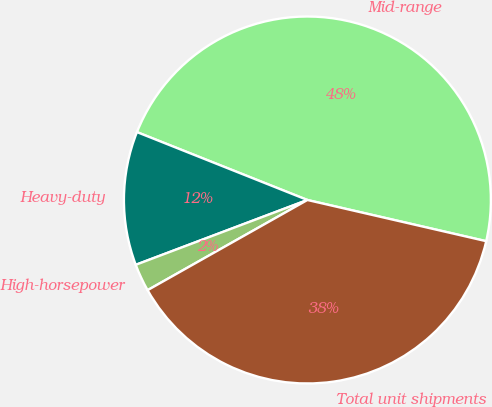<chart> <loc_0><loc_0><loc_500><loc_500><pie_chart><fcel>Mid-range<fcel>Heavy-duty<fcel>High-horsepower<fcel>Total unit shipments<nl><fcel>47.57%<fcel>11.78%<fcel>2.43%<fcel>38.22%<nl></chart> 